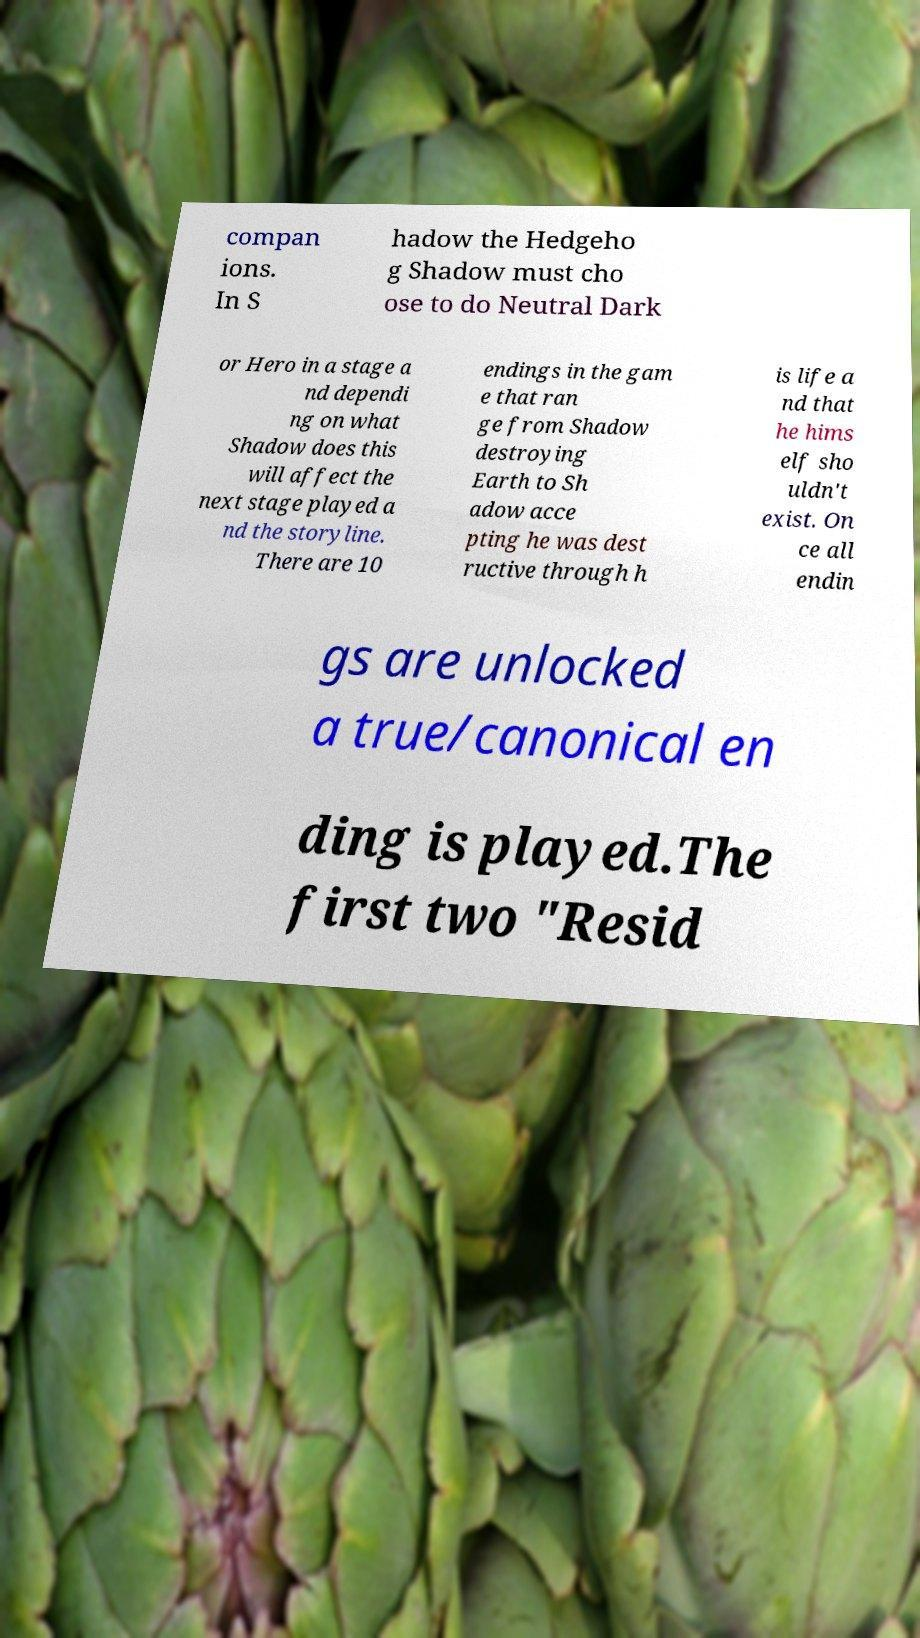I need the written content from this picture converted into text. Can you do that? compan ions. In S hadow the Hedgeho g Shadow must cho ose to do Neutral Dark or Hero in a stage a nd dependi ng on what Shadow does this will affect the next stage played a nd the storyline. There are 10 endings in the gam e that ran ge from Shadow destroying Earth to Sh adow acce pting he was dest ructive through h is life a nd that he hims elf sho uldn't exist. On ce all endin gs are unlocked a true/canonical en ding is played.The first two "Resid 